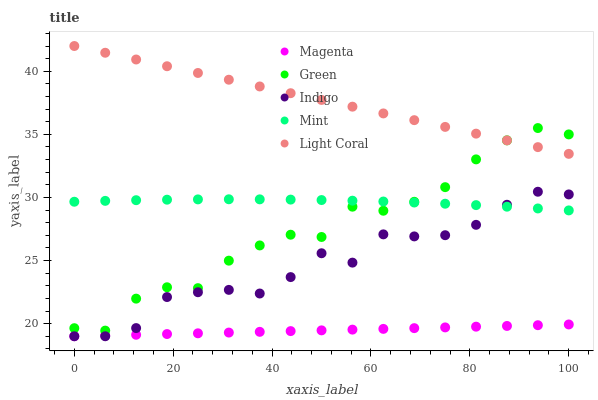Does Magenta have the minimum area under the curve?
Answer yes or no. Yes. Does Light Coral have the maximum area under the curve?
Answer yes or no. Yes. Does Indigo have the minimum area under the curve?
Answer yes or no. No. Does Indigo have the maximum area under the curve?
Answer yes or no. No. Is Magenta the smoothest?
Answer yes or no. Yes. Is Green the roughest?
Answer yes or no. Yes. Is Indigo the smoothest?
Answer yes or no. No. Is Indigo the roughest?
Answer yes or no. No. Does Indigo have the lowest value?
Answer yes or no. Yes. Does Green have the lowest value?
Answer yes or no. No. Does Light Coral have the highest value?
Answer yes or no. Yes. Does Indigo have the highest value?
Answer yes or no. No. Is Mint less than Light Coral?
Answer yes or no. Yes. Is Light Coral greater than Mint?
Answer yes or no. Yes. Does Magenta intersect Indigo?
Answer yes or no. Yes. Is Magenta less than Indigo?
Answer yes or no. No. Is Magenta greater than Indigo?
Answer yes or no. No. Does Mint intersect Light Coral?
Answer yes or no. No. 